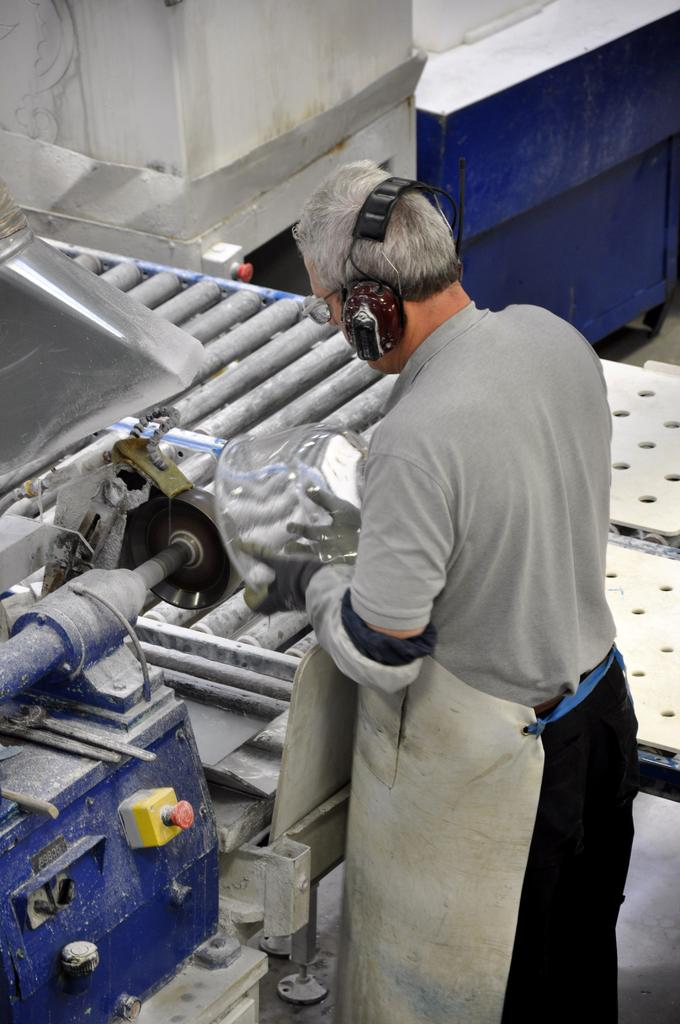What can be seen in the image? There is a person in the image. What is the person wearing? The person is wearing a headset. What is the person holding? The person is holding an object. What is behind the person? The person is standing in front of a machine. What is visible at the top of the image? There is a wall visible at the top of the image. What type of property is the person selling in the image? There is no indication of property or selling in the image; it only shows a person wearing a headset, holding an object, and standing in front of a machine. What kind of lumber is the person using to play the guitar in the image? There is no guitar or lumber present in the image. 